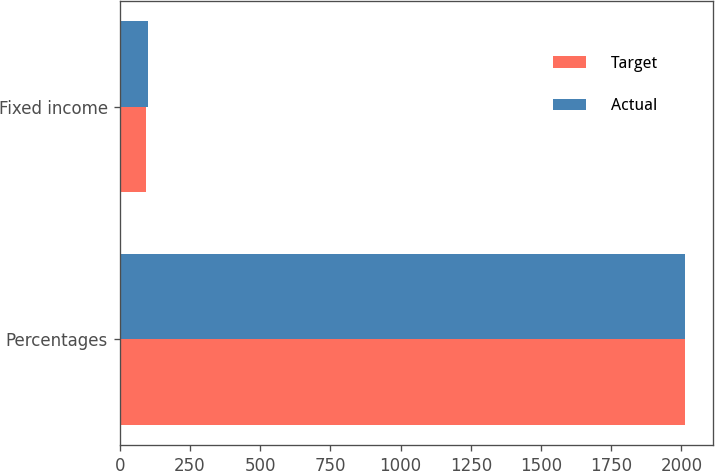Convert chart to OTSL. <chart><loc_0><loc_0><loc_500><loc_500><stacked_bar_chart><ecel><fcel>Percentages<fcel>Fixed income<nl><fcel>Target<fcel>2013<fcel>92<nl><fcel>Actual<fcel>2013<fcel>100<nl></chart> 